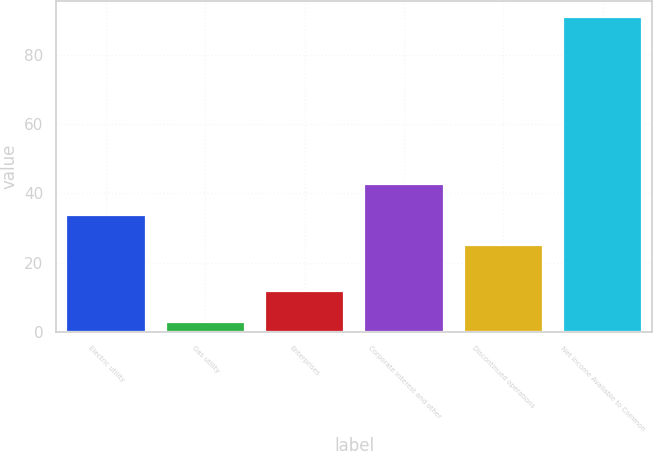<chart> <loc_0><loc_0><loc_500><loc_500><bar_chart><fcel>Electric utility<fcel>Gas utility<fcel>Enterprises<fcel>Corporate interest and other<fcel>Discontinued operations<fcel>Net Income Available to Common<nl><fcel>33.8<fcel>3<fcel>11.8<fcel>42.6<fcel>25<fcel>91<nl></chart> 